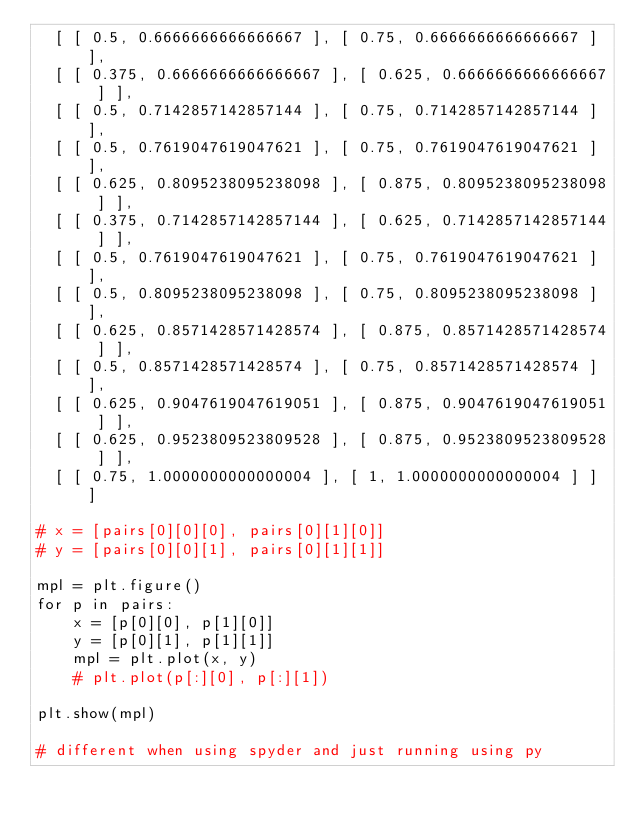<code> <loc_0><loc_0><loc_500><loc_500><_Python_>	[ [ 0.5, 0.6666666666666667 ], [ 0.75, 0.6666666666666667 ] ],
	[ [ 0.375, 0.6666666666666667 ], [ 0.625, 0.6666666666666667 ] ],
	[ [ 0.5, 0.7142857142857144 ], [ 0.75, 0.7142857142857144 ] ],
	[ [ 0.5, 0.7619047619047621 ], [ 0.75, 0.7619047619047621 ] ],
	[ [ 0.625, 0.8095238095238098 ], [ 0.875, 0.8095238095238098 ] ],
	[ [ 0.375, 0.7142857142857144 ], [ 0.625, 0.7142857142857144 ] ],
	[ [ 0.5, 0.7619047619047621 ], [ 0.75, 0.7619047619047621 ] ],
	[ [ 0.5, 0.8095238095238098 ], [ 0.75, 0.8095238095238098 ] ],
	[ [ 0.625, 0.8571428571428574 ], [ 0.875, 0.8571428571428574 ] ],
	[ [ 0.5, 0.8571428571428574 ], [ 0.75, 0.8571428571428574 ] ],
	[ [ 0.625, 0.9047619047619051 ], [ 0.875, 0.9047619047619051 ] ],
	[ [ 0.625, 0.9523809523809528 ], [ 0.875, 0.9523809523809528 ] ],
	[ [ 0.75, 1.0000000000000004 ], [ 1, 1.0000000000000004 ] ] ]

# x = [pairs[0][0][0], pairs[0][1][0]]
# y = [pairs[0][0][1], pairs[0][1][1]]

mpl = plt.figure()
for p in pairs:
		x = [p[0][0], p[1][0]]
		y = [p[0][1], p[1][1]]
		mpl = plt.plot(x, y)
		# plt.plot(p[:][0], p[:][1])

plt.show(mpl)

# different when using spyder and just running using py</code> 